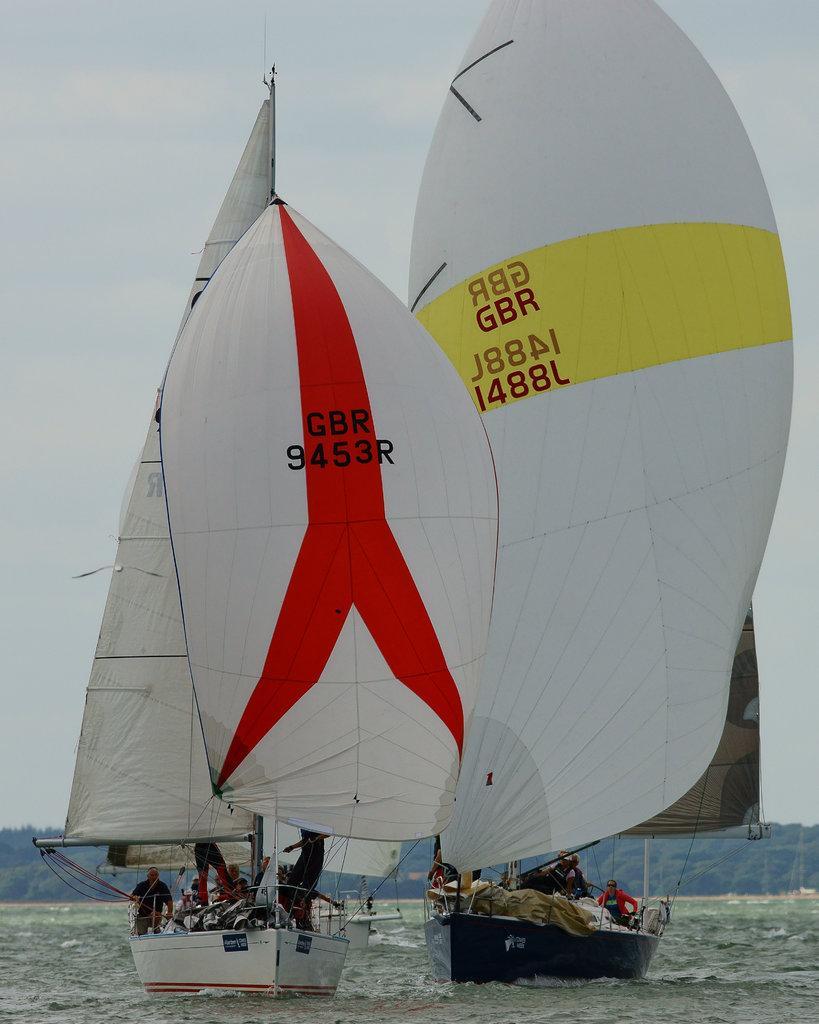Can you describe this image briefly? In this picture we can see few boats on the water, and we can find few people in the boats, in the background we can see few trees. 